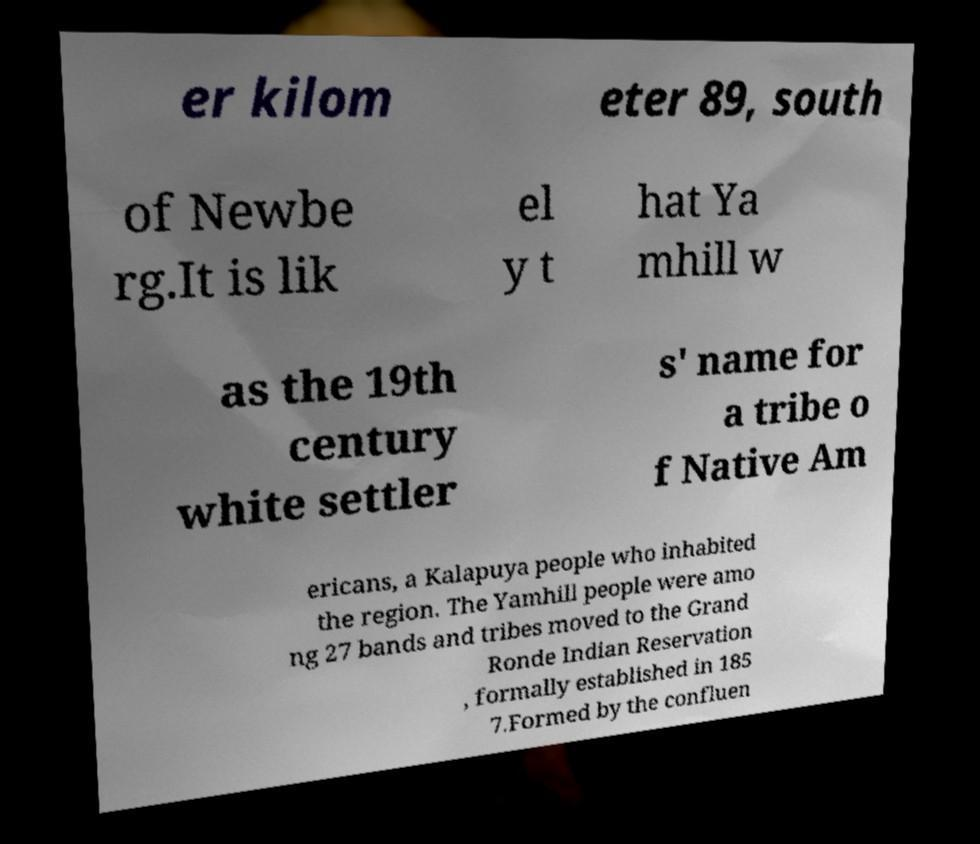I need the written content from this picture converted into text. Can you do that? er kilom eter 89, south of Newbe rg.It is lik el y t hat Ya mhill w as the 19th century white settler s' name for a tribe o f Native Am ericans, a Kalapuya people who inhabited the region. The Yamhill people were amo ng 27 bands and tribes moved to the Grand Ronde Indian Reservation , formally established in 185 7.Formed by the confluen 